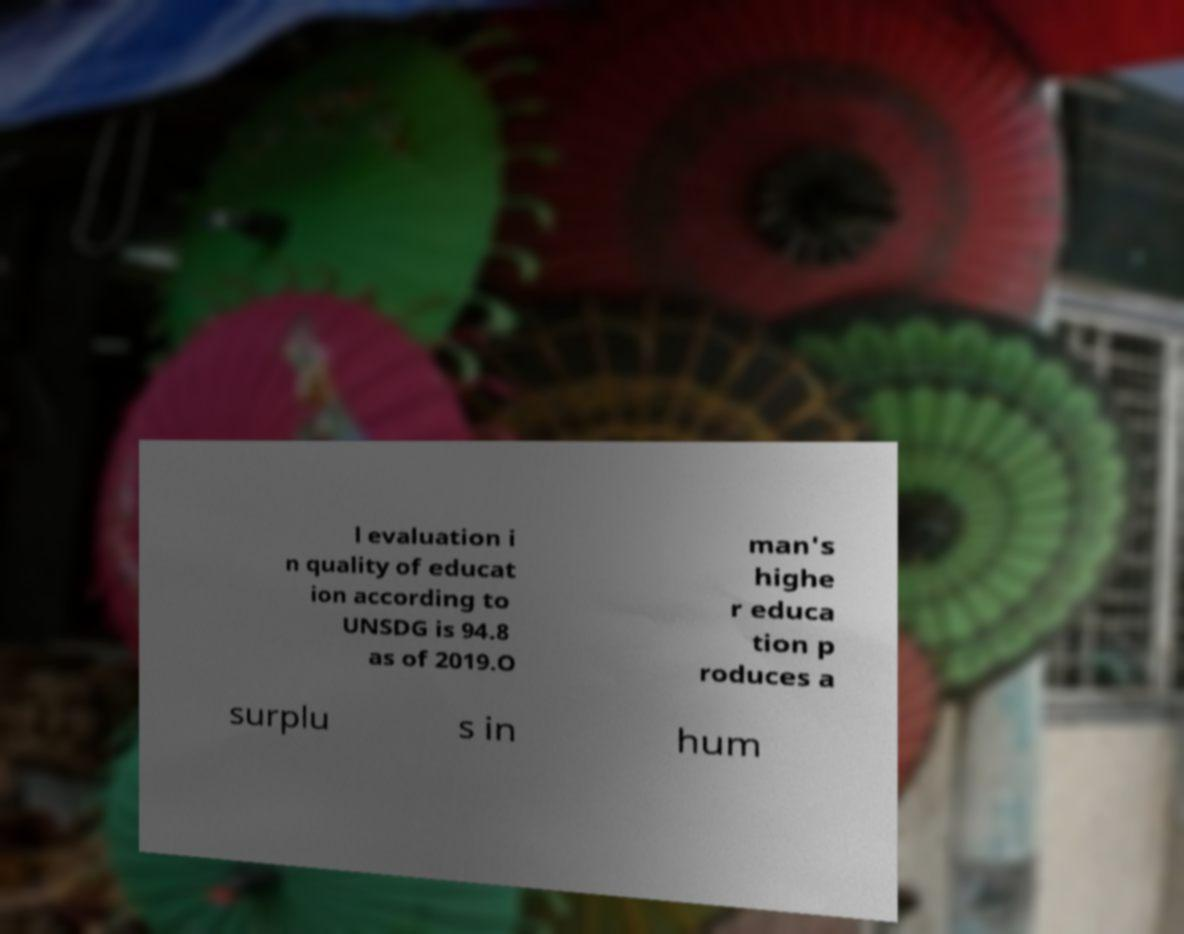Please identify and transcribe the text found in this image. l evaluation i n quality of educat ion according to UNSDG is 94.8 as of 2019.O man's highe r educa tion p roduces a surplu s in hum 